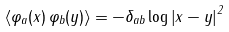Convert formula to latex. <formula><loc_0><loc_0><loc_500><loc_500>\left \langle \varphi _ { a } ( x ) \, \varphi _ { b } ( y ) \right \rangle = - \delta _ { a b } \log \left | x - y \right | ^ { 2 }</formula> 